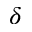Convert formula to latex. <formula><loc_0><loc_0><loc_500><loc_500>\delta</formula> 